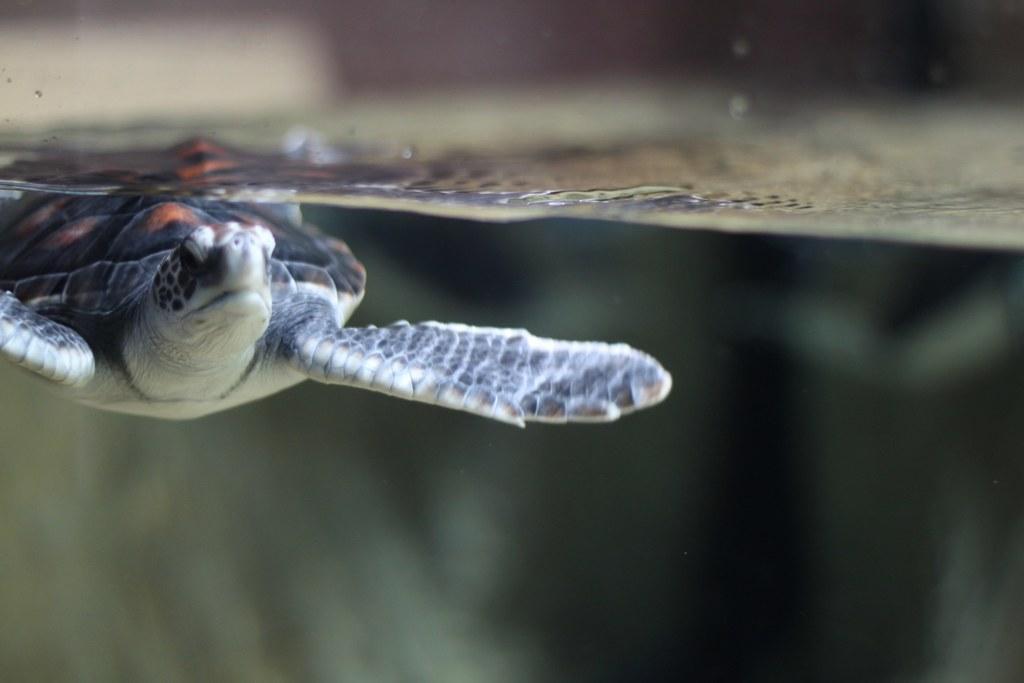Please provide a concise description of this image. In this image there is a tortoise in the inverted direction. 